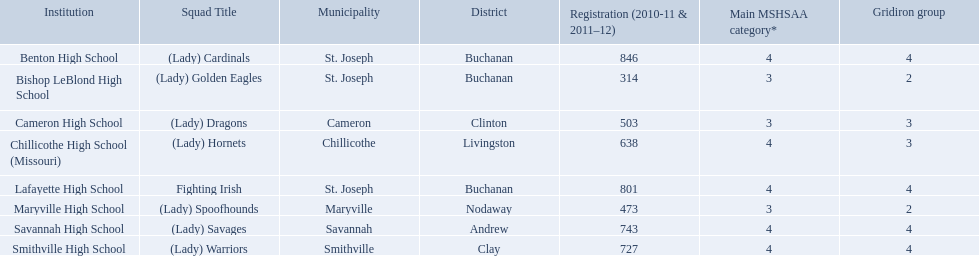What team uses green and grey as colors? Fighting Irish. What is this team called? Lafayette High School. What are the three schools in the town of st. joseph? St. Joseph, St. Joseph, St. Joseph. Of the three schools in st. joseph which school's team name does not depict a type of animal? Lafayette High School. Could you help me parse every detail presented in this table? {'header': ['Institution', 'Squad Title', 'Municipality', 'District', 'Registration (2010-11 & 2011–12)', 'Main MSHSAA category*', 'Gridiron group'], 'rows': [['Benton High School', '(Lady) Cardinals', 'St. Joseph', 'Buchanan', '846', '4', '4'], ['Bishop LeBlond High School', '(Lady) Golden Eagles', 'St. Joseph', 'Buchanan', '314', '3', '2'], ['Cameron High School', '(Lady) Dragons', 'Cameron', 'Clinton', '503', '3', '3'], ['Chillicothe High School (Missouri)', '(Lady) Hornets', 'Chillicothe', 'Livingston', '638', '4', '3'], ['Lafayette High School', 'Fighting Irish', 'St. Joseph', 'Buchanan', '801', '4', '4'], ['Maryville High School', '(Lady) Spoofhounds', 'Maryville', 'Nodaway', '473', '3', '2'], ['Savannah High School', '(Lady) Savages', 'Savannah', 'Andrew', '743', '4', '4'], ['Smithville High School', '(Lady) Warriors', 'Smithville', 'Clay', '727', '4', '4']]} What are all of the schools? Benton High School, Bishop LeBlond High School, Cameron High School, Chillicothe High School (Missouri), Lafayette High School, Maryville High School, Savannah High School, Smithville High School. How many football classes do they have? 4, 2, 3, 3, 4, 2, 4, 4. What about their enrollment? 846, 314, 503, 638, 801, 473, 743, 727. Which schools have 3 football classes? Cameron High School, Chillicothe High School (Missouri). And of those schools, which has 638 students? Chillicothe High School (Missouri). What were the schools enrolled in 2010-2011 Benton High School, Bishop LeBlond High School, Cameron High School, Chillicothe High School (Missouri), Lafayette High School, Maryville High School, Savannah High School, Smithville High School. How many were enrolled in each? 846, 314, 503, 638, 801, 473, 743, 727. Which is the lowest number? 314. Which school had this number of students? Bishop LeBlond High School. 